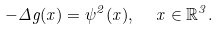Convert formula to latex. <formula><loc_0><loc_0><loc_500><loc_500>- \Delta g ( x ) = \psi ^ { 2 } ( x ) , \ \ x \in \mathbb { R } ^ { 3 } .</formula> 